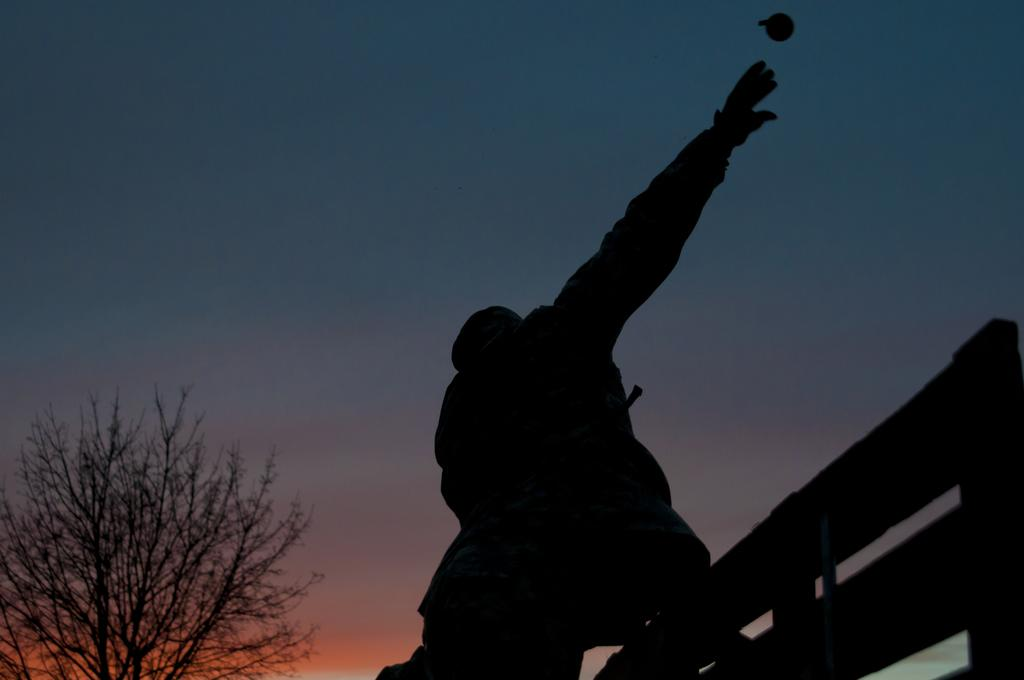Who or what is present in the image? There is a person in the image. What can be seen in the image besides the person? There are dark objects in the image. What is visible in the background of the image? There is a tree and the sky visible in the background of the image. How does the wind affect the things in the image? There is no mention of wind or things in the image, so it is not possible to determine how the wind might affect them. 